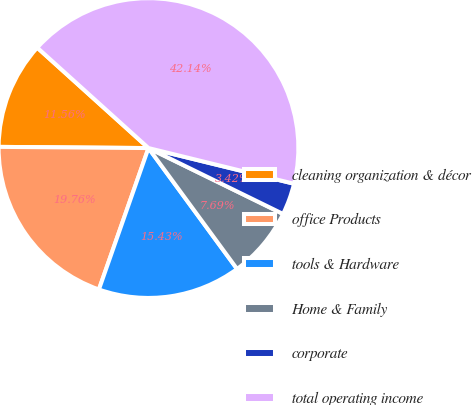Convert chart to OTSL. <chart><loc_0><loc_0><loc_500><loc_500><pie_chart><fcel>cleaning organization & décor<fcel>office Products<fcel>tools & Hardware<fcel>Home & Family<fcel>corporate<fcel>total operating income<nl><fcel>11.56%<fcel>19.76%<fcel>15.43%<fcel>7.69%<fcel>3.42%<fcel>42.14%<nl></chart> 